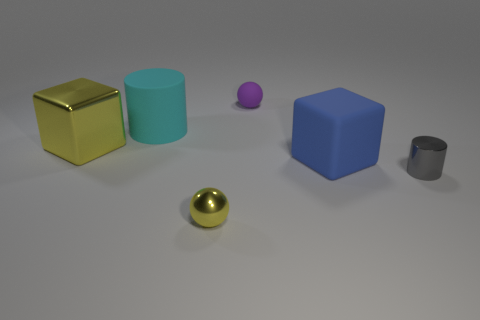Are there fewer large blue objects that are behind the purple matte object than tiny matte spheres that are behind the blue rubber cube?
Keep it short and to the point. Yes. There is a cube that is on the right side of the small yellow object; is it the same color as the tiny thing that is behind the big cylinder?
Make the answer very short. No. Are there any other big objects that have the same material as the big blue object?
Make the answer very short. Yes. What size is the ball that is in front of the tiny sphere behind the small shiny cylinder?
Provide a short and direct response. Small. Is the number of purple matte balls greater than the number of tiny blue metal objects?
Provide a short and direct response. Yes. Is the size of the yellow shiny object that is to the left of the cyan matte cylinder the same as the tiny metal ball?
Your answer should be very brief. No. What number of objects are the same color as the big matte cube?
Make the answer very short. 0. Is the shape of the tiny rubber object the same as the tiny yellow shiny object?
Offer a terse response. Yes. What size is the other matte thing that is the same shape as the gray object?
Keep it short and to the point. Large. Are there more tiny spheres to the left of the yellow metallic cube than tiny metal objects on the left side of the gray metal cylinder?
Your answer should be compact. No. 